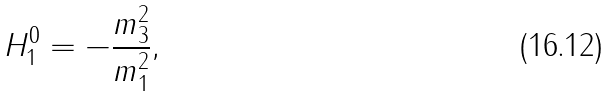Convert formula to latex. <formula><loc_0><loc_0><loc_500><loc_500>H _ { 1 } ^ { 0 } = - \frac { m _ { 3 } ^ { 2 } } { m _ { 1 } ^ { 2 } } ,</formula> 